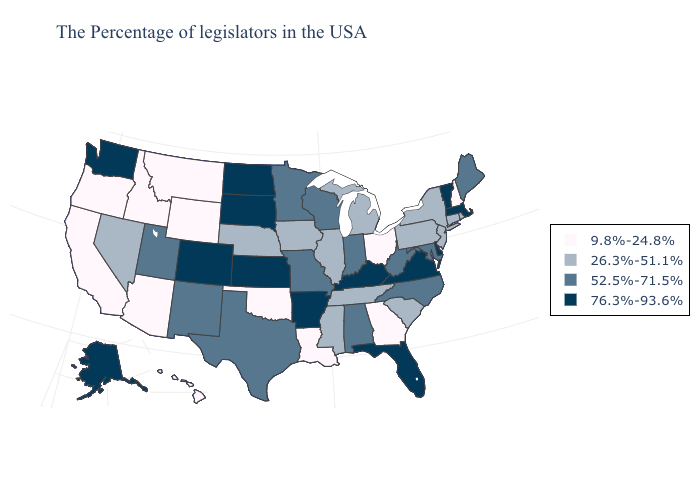Name the states that have a value in the range 76.3%-93.6%?
Answer briefly. Massachusetts, Vermont, Delaware, Virginia, Florida, Kentucky, Arkansas, Kansas, South Dakota, North Dakota, Colorado, Washington, Alaska. What is the value of Nevada?
Answer briefly. 26.3%-51.1%. Name the states that have a value in the range 52.5%-71.5%?
Be succinct. Maine, Maryland, North Carolina, West Virginia, Indiana, Alabama, Wisconsin, Missouri, Minnesota, Texas, New Mexico, Utah. What is the highest value in states that border Minnesota?
Concise answer only. 76.3%-93.6%. Name the states that have a value in the range 9.8%-24.8%?
Concise answer only. New Hampshire, Ohio, Georgia, Louisiana, Oklahoma, Wyoming, Montana, Arizona, Idaho, California, Oregon, Hawaii. Does West Virginia have the lowest value in the South?
Give a very brief answer. No. Which states have the lowest value in the USA?
Keep it brief. New Hampshire, Ohio, Georgia, Louisiana, Oklahoma, Wyoming, Montana, Arizona, Idaho, California, Oregon, Hawaii. Does Florida have the lowest value in the USA?
Be succinct. No. Name the states that have a value in the range 52.5%-71.5%?
Be succinct. Maine, Maryland, North Carolina, West Virginia, Indiana, Alabama, Wisconsin, Missouri, Minnesota, Texas, New Mexico, Utah. What is the value of Iowa?
Quick response, please. 26.3%-51.1%. Name the states that have a value in the range 76.3%-93.6%?
Write a very short answer. Massachusetts, Vermont, Delaware, Virginia, Florida, Kentucky, Arkansas, Kansas, South Dakota, North Dakota, Colorado, Washington, Alaska. What is the lowest value in the USA?
Write a very short answer. 9.8%-24.8%. What is the highest value in states that border Minnesota?
Give a very brief answer. 76.3%-93.6%. Which states have the highest value in the USA?
Quick response, please. Massachusetts, Vermont, Delaware, Virginia, Florida, Kentucky, Arkansas, Kansas, South Dakota, North Dakota, Colorado, Washington, Alaska. Among the states that border Wyoming , which have the lowest value?
Short answer required. Montana, Idaho. 